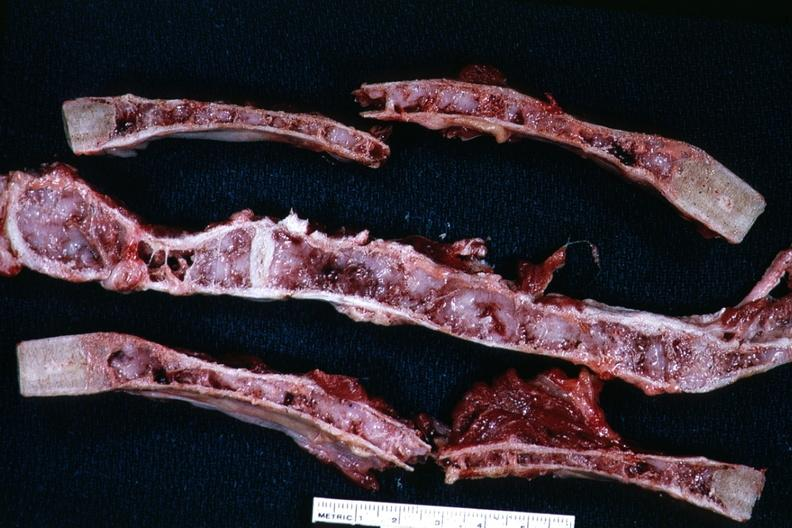where is this?
Answer the question using a single word or phrase. Thorax 